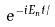<formula> <loc_0><loc_0><loc_500><loc_500>e ^ { - i E _ { n } t / }</formula> 